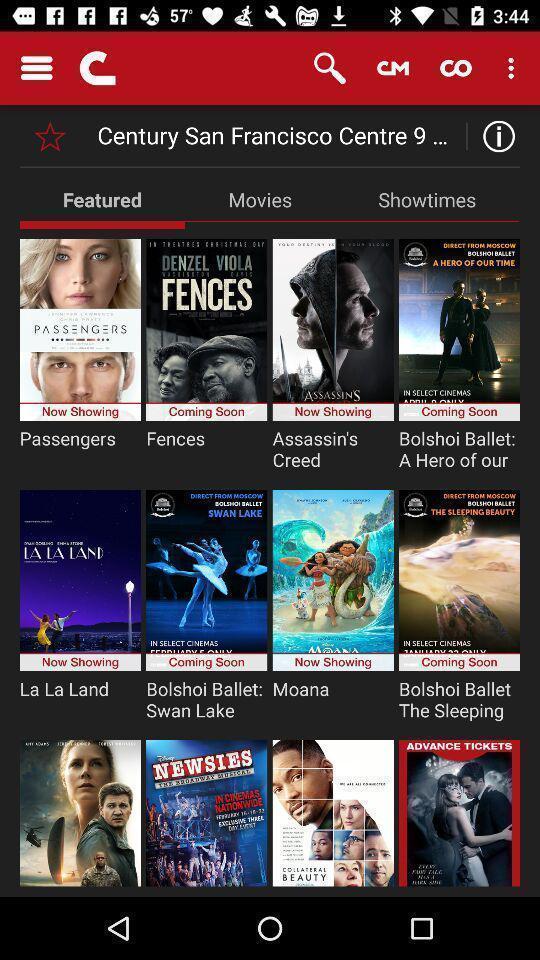Tell me what you see in this picture. Screen shows featured movies on a device. 